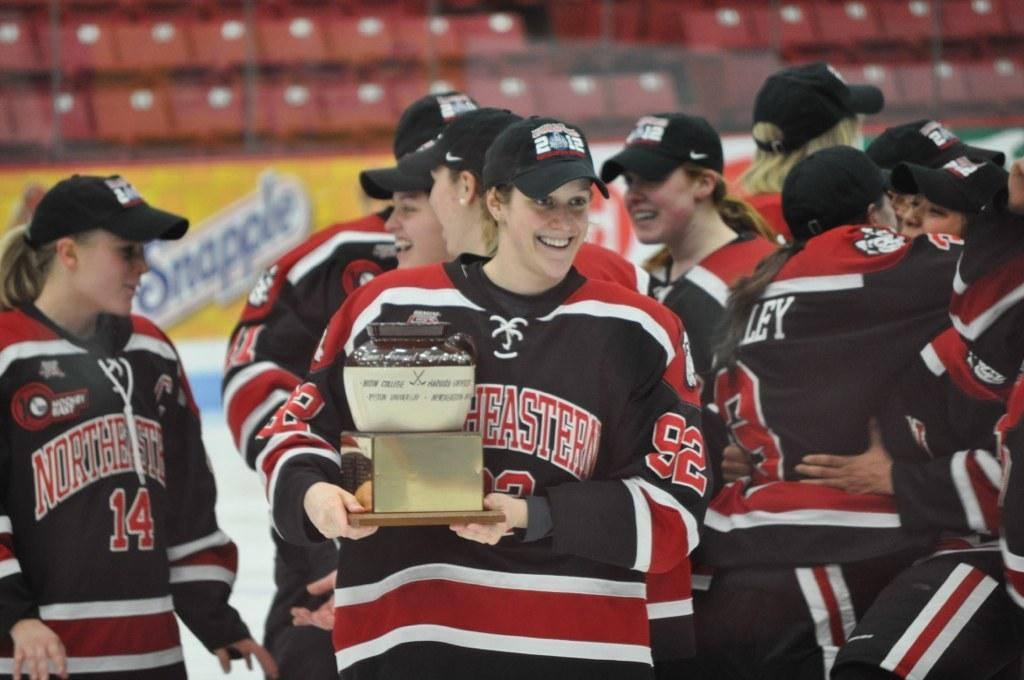<image>
Relay a brief, clear account of the picture shown. A team from Northwestern is celebrating a victory and one team member holds an award. 